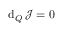Convert formula to latex. <formula><loc_0><loc_0><loc_500><loc_500>d _ { Q } \, \mathcal { J } = 0</formula> 